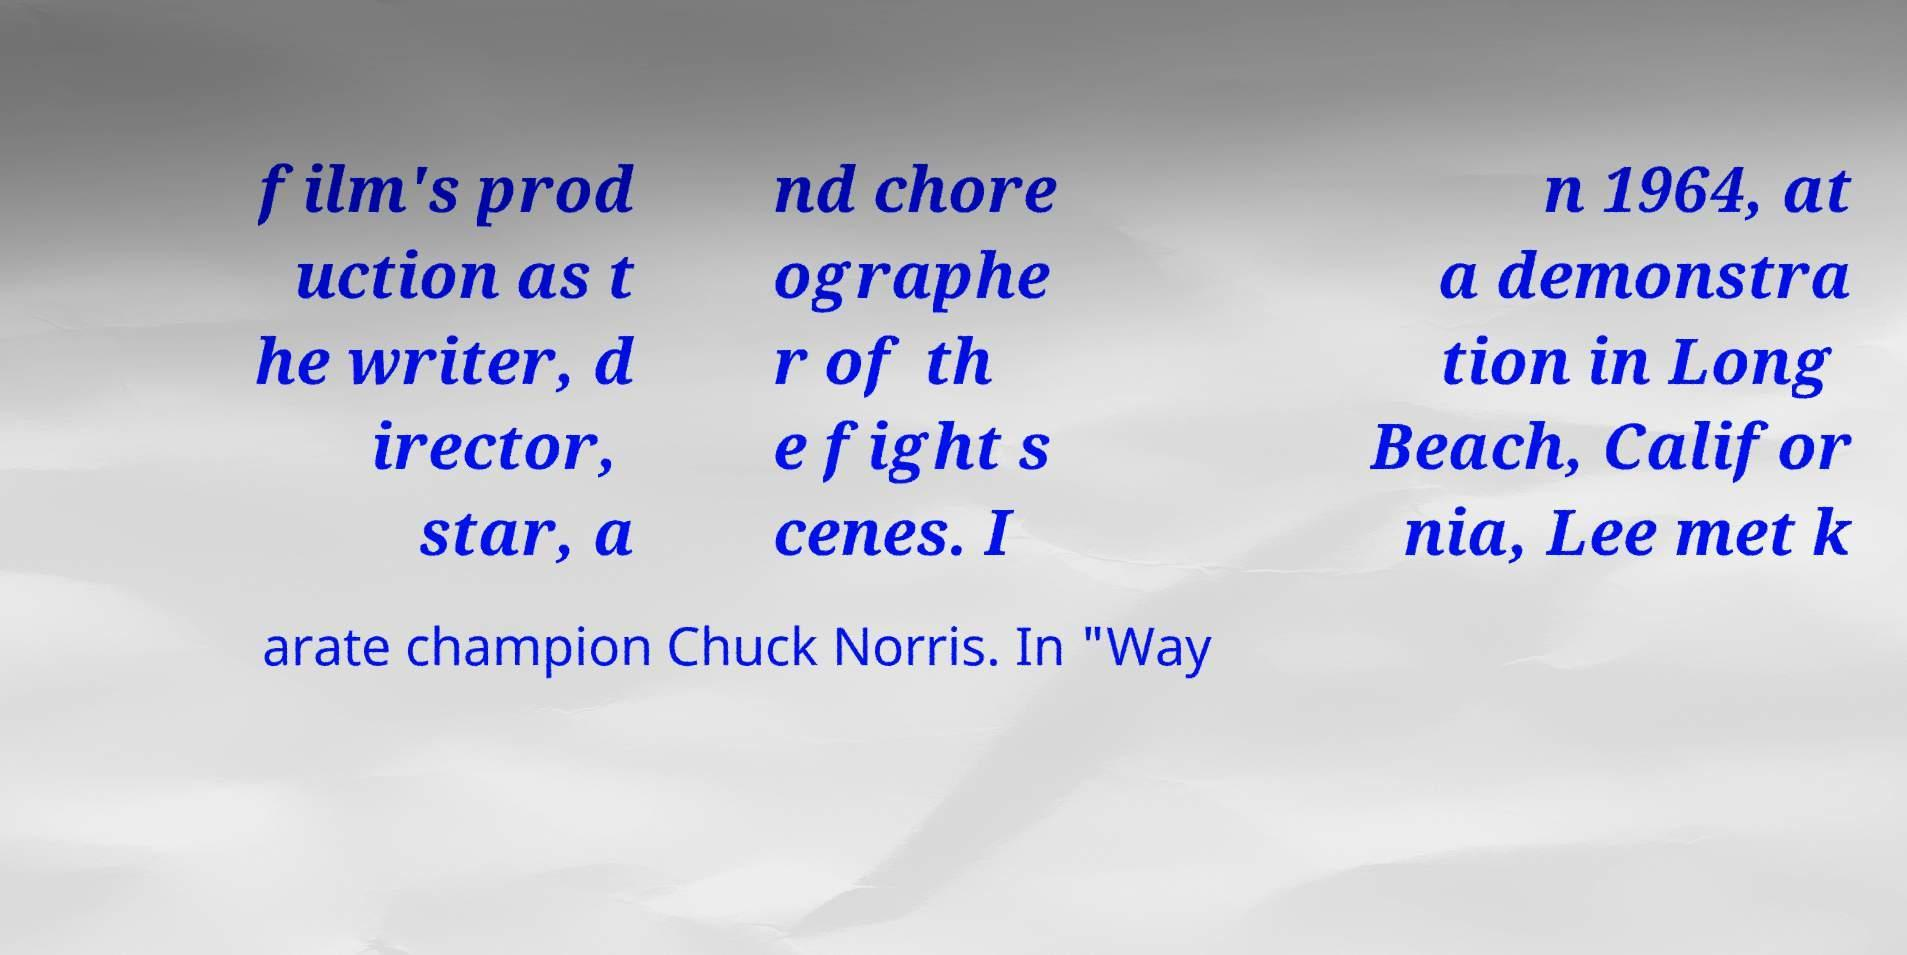For documentation purposes, I need the text within this image transcribed. Could you provide that? film's prod uction as t he writer, d irector, star, a nd chore ographe r of th e fight s cenes. I n 1964, at a demonstra tion in Long Beach, Califor nia, Lee met k arate champion Chuck Norris. In "Way 